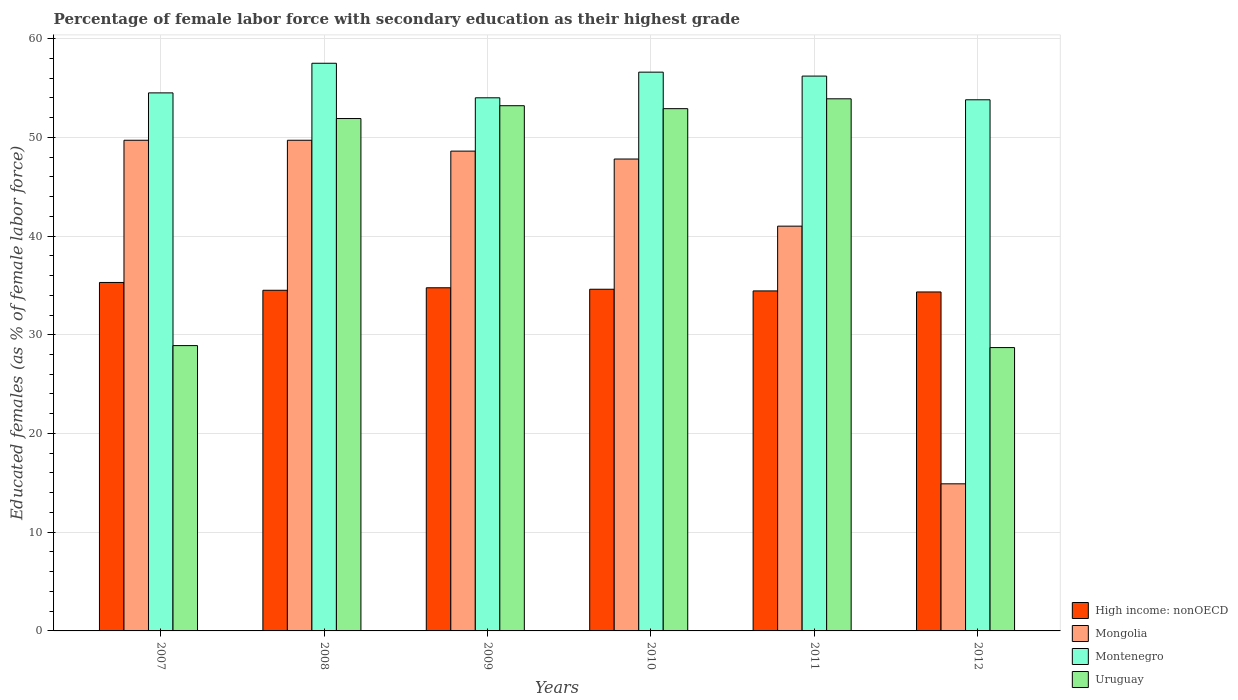How many groups of bars are there?
Your response must be concise. 6. How many bars are there on the 5th tick from the left?
Make the answer very short. 4. How many bars are there on the 1st tick from the right?
Give a very brief answer. 4. In how many cases, is the number of bars for a given year not equal to the number of legend labels?
Provide a succinct answer. 0. What is the percentage of female labor force with secondary education in Mongolia in 2008?
Provide a short and direct response. 49.7. Across all years, what is the maximum percentage of female labor force with secondary education in Uruguay?
Make the answer very short. 53.9. Across all years, what is the minimum percentage of female labor force with secondary education in Montenegro?
Offer a very short reply. 53.8. In which year was the percentage of female labor force with secondary education in Uruguay minimum?
Keep it short and to the point. 2012. What is the total percentage of female labor force with secondary education in High income: nonOECD in the graph?
Give a very brief answer. 207.94. What is the difference between the percentage of female labor force with secondary education in Montenegro in 2011 and that in 2012?
Offer a very short reply. 2.4. What is the difference between the percentage of female labor force with secondary education in Mongolia in 2009 and the percentage of female labor force with secondary education in Montenegro in 2012?
Your answer should be very brief. -5.2. What is the average percentage of female labor force with secondary education in Mongolia per year?
Offer a very short reply. 41.95. In the year 2009, what is the difference between the percentage of female labor force with secondary education in Uruguay and percentage of female labor force with secondary education in Montenegro?
Provide a short and direct response. -0.8. What is the ratio of the percentage of female labor force with secondary education in High income: nonOECD in 2008 to that in 2012?
Offer a very short reply. 1. Is the difference between the percentage of female labor force with secondary education in Uruguay in 2010 and 2012 greater than the difference between the percentage of female labor force with secondary education in Montenegro in 2010 and 2012?
Provide a succinct answer. Yes. What is the difference between the highest and the second highest percentage of female labor force with secondary education in Uruguay?
Your response must be concise. 0.7. What is the difference between the highest and the lowest percentage of female labor force with secondary education in High income: nonOECD?
Give a very brief answer. 0.96. In how many years, is the percentage of female labor force with secondary education in Uruguay greater than the average percentage of female labor force with secondary education in Uruguay taken over all years?
Your response must be concise. 4. What does the 4th bar from the left in 2012 represents?
Offer a very short reply. Uruguay. What does the 1st bar from the right in 2010 represents?
Keep it short and to the point. Uruguay. Are all the bars in the graph horizontal?
Your answer should be compact. No. Are the values on the major ticks of Y-axis written in scientific E-notation?
Your answer should be compact. No. Does the graph contain any zero values?
Give a very brief answer. No. Where does the legend appear in the graph?
Make the answer very short. Bottom right. What is the title of the graph?
Provide a succinct answer. Percentage of female labor force with secondary education as their highest grade. Does "Barbados" appear as one of the legend labels in the graph?
Give a very brief answer. No. What is the label or title of the X-axis?
Make the answer very short. Years. What is the label or title of the Y-axis?
Give a very brief answer. Educated females (as % of female labor force). What is the Educated females (as % of female labor force) of High income: nonOECD in 2007?
Provide a succinct answer. 35.3. What is the Educated females (as % of female labor force) in Mongolia in 2007?
Your answer should be very brief. 49.7. What is the Educated females (as % of female labor force) of Montenegro in 2007?
Ensure brevity in your answer.  54.5. What is the Educated females (as % of female labor force) in Uruguay in 2007?
Keep it short and to the point. 28.9. What is the Educated females (as % of female labor force) in High income: nonOECD in 2008?
Keep it short and to the point. 34.51. What is the Educated females (as % of female labor force) of Mongolia in 2008?
Your response must be concise. 49.7. What is the Educated females (as % of female labor force) in Montenegro in 2008?
Make the answer very short. 57.5. What is the Educated females (as % of female labor force) of Uruguay in 2008?
Give a very brief answer. 51.9. What is the Educated females (as % of female labor force) of High income: nonOECD in 2009?
Ensure brevity in your answer.  34.76. What is the Educated females (as % of female labor force) in Mongolia in 2009?
Provide a succinct answer. 48.6. What is the Educated females (as % of female labor force) of Montenegro in 2009?
Offer a very short reply. 54. What is the Educated females (as % of female labor force) of Uruguay in 2009?
Provide a short and direct response. 53.2. What is the Educated females (as % of female labor force) of High income: nonOECD in 2010?
Make the answer very short. 34.61. What is the Educated females (as % of female labor force) in Mongolia in 2010?
Your answer should be compact. 47.8. What is the Educated females (as % of female labor force) in Montenegro in 2010?
Your response must be concise. 56.6. What is the Educated females (as % of female labor force) in Uruguay in 2010?
Your response must be concise. 52.9. What is the Educated females (as % of female labor force) in High income: nonOECD in 2011?
Your answer should be compact. 34.44. What is the Educated females (as % of female labor force) of Mongolia in 2011?
Make the answer very short. 41. What is the Educated females (as % of female labor force) of Montenegro in 2011?
Your response must be concise. 56.2. What is the Educated females (as % of female labor force) of Uruguay in 2011?
Ensure brevity in your answer.  53.9. What is the Educated females (as % of female labor force) in High income: nonOECD in 2012?
Your response must be concise. 34.33. What is the Educated females (as % of female labor force) of Mongolia in 2012?
Your response must be concise. 14.9. What is the Educated females (as % of female labor force) of Montenegro in 2012?
Make the answer very short. 53.8. What is the Educated females (as % of female labor force) in Uruguay in 2012?
Your answer should be compact. 28.7. Across all years, what is the maximum Educated females (as % of female labor force) of High income: nonOECD?
Offer a terse response. 35.3. Across all years, what is the maximum Educated females (as % of female labor force) in Mongolia?
Make the answer very short. 49.7. Across all years, what is the maximum Educated females (as % of female labor force) in Montenegro?
Your answer should be compact. 57.5. Across all years, what is the maximum Educated females (as % of female labor force) in Uruguay?
Offer a terse response. 53.9. Across all years, what is the minimum Educated females (as % of female labor force) of High income: nonOECD?
Your answer should be compact. 34.33. Across all years, what is the minimum Educated females (as % of female labor force) in Mongolia?
Your answer should be very brief. 14.9. Across all years, what is the minimum Educated females (as % of female labor force) in Montenegro?
Your response must be concise. 53.8. Across all years, what is the minimum Educated females (as % of female labor force) of Uruguay?
Give a very brief answer. 28.7. What is the total Educated females (as % of female labor force) in High income: nonOECD in the graph?
Ensure brevity in your answer.  207.94. What is the total Educated females (as % of female labor force) in Mongolia in the graph?
Your answer should be compact. 251.7. What is the total Educated females (as % of female labor force) of Montenegro in the graph?
Give a very brief answer. 332.6. What is the total Educated females (as % of female labor force) of Uruguay in the graph?
Your answer should be very brief. 269.5. What is the difference between the Educated females (as % of female labor force) of High income: nonOECD in 2007 and that in 2008?
Your answer should be compact. 0.79. What is the difference between the Educated females (as % of female labor force) of Uruguay in 2007 and that in 2008?
Ensure brevity in your answer.  -23. What is the difference between the Educated females (as % of female labor force) of High income: nonOECD in 2007 and that in 2009?
Ensure brevity in your answer.  0.54. What is the difference between the Educated females (as % of female labor force) in Uruguay in 2007 and that in 2009?
Keep it short and to the point. -24.3. What is the difference between the Educated females (as % of female labor force) of High income: nonOECD in 2007 and that in 2010?
Offer a very short reply. 0.69. What is the difference between the Educated females (as % of female labor force) of Uruguay in 2007 and that in 2010?
Your answer should be compact. -24. What is the difference between the Educated females (as % of female labor force) in High income: nonOECD in 2007 and that in 2011?
Your answer should be compact. 0.86. What is the difference between the Educated females (as % of female labor force) in Mongolia in 2007 and that in 2011?
Provide a succinct answer. 8.7. What is the difference between the Educated females (as % of female labor force) of High income: nonOECD in 2007 and that in 2012?
Offer a very short reply. 0.96. What is the difference between the Educated females (as % of female labor force) in Mongolia in 2007 and that in 2012?
Your answer should be very brief. 34.8. What is the difference between the Educated females (as % of female labor force) in High income: nonOECD in 2008 and that in 2009?
Offer a terse response. -0.25. What is the difference between the Educated females (as % of female labor force) of Montenegro in 2008 and that in 2009?
Make the answer very short. 3.5. What is the difference between the Educated females (as % of female labor force) in Uruguay in 2008 and that in 2009?
Give a very brief answer. -1.3. What is the difference between the Educated females (as % of female labor force) of High income: nonOECD in 2008 and that in 2010?
Your answer should be very brief. -0.11. What is the difference between the Educated females (as % of female labor force) in Mongolia in 2008 and that in 2010?
Your response must be concise. 1.9. What is the difference between the Educated females (as % of female labor force) in Montenegro in 2008 and that in 2010?
Provide a short and direct response. 0.9. What is the difference between the Educated females (as % of female labor force) in High income: nonOECD in 2008 and that in 2011?
Provide a succinct answer. 0.07. What is the difference between the Educated females (as % of female labor force) in Mongolia in 2008 and that in 2011?
Ensure brevity in your answer.  8.7. What is the difference between the Educated females (as % of female labor force) of Montenegro in 2008 and that in 2011?
Give a very brief answer. 1.3. What is the difference between the Educated females (as % of female labor force) of Uruguay in 2008 and that in 2011?
Your response must be concise. -2. What is the difference between the Educated females (as % of female labor force) of High income: nonOECD in 2008 and that in 2012?
Your response must be concise. 0.17. What is the difference between the Educated females (as % of female labor force) in Mongolia in 2008 and that in 2012?
Offer a very short reply. 34.8. What is the difference between the Educated females (as % of female labor force) of Uruguay in 2008 and that in 2012?
Give a very brief answer. 23.2. What is the difference between the Educated females (as % of female labor force) of High income: nonOECD in 2009 and that in 2010?
Offer a terse response. 0.15. What is the difference between the Educated females (as % of female labor force) of Mongolia in 2009 and that in 2010?
Provide a short and direct response. 0.8. What is the difference between the Educated females (as % of female labor force) of Montenegro in 2009 and that in 2010?
Give a very brief answer. -2.6. What is the difference between the Educated females (as % of female labor force) of Uruguay in 2009 and that in 2010?
Provide a succinct answer. 0.3. What is the difference between the Educated females (as % of female labor force) of High income: nonOECD in 2009 and that in 2011?
Your answer should be compact. 0.32. What is the difference between the Educated females (as % of female labor force) in Montenegro in 2009 and that in 2011?
Ensure brevity in your answer.  -2.2. What is the difference between the Educated females (as % of female labor force) in Uruguay in 2009 and that in 2011?
Your answer should be very brief. -0.7. What is the difference between the Educated females (as % of female labor force) of High income: nonOECD in 2009 and that in 2012?
Provide a short and direct response. 0.42. What is the difference between the Educated females (as % of female labor force) in Mongolia in 2009 and that in 2012?
Make the answer very short. 33.7. What is the difference between the Educated females (as % of female labor force) in Uruguay in 2009 and that in 2012?
Provide a short and direct response. 24.5. What is the difference between the Educated females (as % of female labor force) in High income: nonOECD in 2010 and that in 2011?
Keep it short and to the point. 0.17. What is the difference between the Educated females (as % of female labor force) in High income: nonOECD in 2010 and that in 2012?
Make the answer very short. 0.28. What is the difference between the Educated females (as % of female labor force) in Mongolia in 2010 and that in 2012?
Provide a short and direct response. 32.9. What is the difference between the Educated females (as % of female labor force) of Uruguay in 2010 and that in 2012?
Provide a short and direct response. 24.2. What is the difference between the Educated females (as % of female labor force) of High income: nonOECD in 2011 and that in 2012?
Ensure brevity in your answer.  0.11. What is the difference between the Educated females (as % of female labor force) of Mongolia in 2011 and that in 2012?
Give a very brief answer. 26.1. What is the difference between the Educated females (as % of female labor force) in Uruguay in 2011 and that in 2012?
Ensure brevity in your answer.  25.2. What is the difference between the Educated females (as % of female labor force) of High income: nonOECD in 2007 and the Educated females (as % of female labor force) of Mongolia in 2008?
Offer a terse response. -14.4. What is the difference between the Educated females (as % of female labor force) of High income: nonOECD in 2007 and the Educated females (as % of female labor force) of Montenegro in 2008?
Make the answer very short. -22.2. What is the difference between the Educated females (as % of female labor force) in High income: nonOECD in 2007 and the Educated females (as % of female labor force) in Uruguay in 2008?
Your response must be concise. -16.6. What is the difference between the Educated females (as % of female labor force) of Mongolia in 2007 and the Educated females (as % of female labor force) of Uruguay in 2008?
Ensure brevity in your answer.  -2.2. What is the difference between the Educated females (as % of female labor force) in Montenegro in 2007 and the Educated females (as % of female labor force) in Uruguay in 2008?
Make the answer very short. 2.6. What is the difference between the Educated females (as % of female labor force) in High income: nonOECD in 2007 and the Educated females (as % of female labor force) in Mongolia in 2009?
Offer a very short reply. -13.3. What is the difference between the Educated females (as % of female labor force) in High income: nonOECD in 2007 and the Educated females (as % of female labor force) in Montenegro in 2009?
Provide a short and direct response. -18.7. What is the difference between the Educated females (as % of female labor force) in High income: nonOECD in 2007 and the Educated females (as % of female labor force) in Uruguay in 2009?
Offer a terse response. -17.9. What is the difference between the Educated females (as % of female labor force) of Mongolia in 2007 and the Educated females (as % of female labor force) of Uruguay in 2009?
Ensure brevity in your answer.  -3.5. What is the difference between the Educated females (as % of female labor force) in High income: nonOECD in 2007 and the Educated females (as % of female labor force) in Mongolia in 2010?
Offer a very short reply. -12.5. What is the difference between the Educated females (as % of female labor force) of High income: nonOECD in 2007 and the Educated females (as % of female labor force) of Montenegro in 2010?
Make the answer very short. -21.3. What is the difference between the Educated females (as % of female labor force) of High income: nonOECD in 2007 and the Educated females (as % of female labor force) of Uruguay in 2010?
Your response must be concise. -17.6. What is the difference between the Educated females (as % of female labor force) of Mongolia in 2007 and the Educated females (as % of female labor force) of Uruguay in 2010?
Give a very brief answer. -3.2. What is the difference between the Educated females (as % of female labor force) in Montenegro in 2007 and the Educated females (as % of female labor force) in Uruguay in 2010?
Your response must be concise. 1.6. What is the difference between the Educated females (as % of female labor force) in High income: nonOECD in 2007 and the Educated females (as % of female labor force) in Mongolia in 2011?
Make the answer very short. -5.7. What is the difference between the Educated females (as % of female labor force) in High income: nonOECD in 2007 and the Educated females (as % of female labor force) in Montenegro in 2011?
Offer a terse response. -20.9. What is the difference between the Educated females (as % of female labor force) of High income: nonOECD in 2007 and the Educated females (as % of female labor force) of Uruguay in 2011?
Ensure brevity in your answer.  -18.6. What is the difference between the Educated females (as % of female labor force) in Mongolia in 2007 and the Educated females (as % of female labor force) in Montenegro in 2011?
Make the answer very short. -6.5. What is the difference between the Educated females (as % of female labor force) in Mongolia in 2007 and the Educated females (as % of female labor force) in Uruguay in 2011?
Your response must be concise. -4.2. What is the difference between the Educated females (as % of female labor force) in Montenegro in 2007 and the Educated females (as % of female labor force) in Uruguay in 2011?
Give a very brief answer. 0.6. What is the difference between the Educated females (as % of female labor force) of High income: nonOECD in 2007 and the Educated females (as % of female labor force) of Mongolia in 2012?
Offer a very short reply. 20.4. What is the difference between the Educated females (as % of female labor force) in High income: nonOECD in 2007 and the Educated females (as % of female labor force) in Montenegro in 2012?
Keep it short and to the point. -18.5. What is the difference between the Educated females (as % of female labor force) in High income: nonOECD in 2007 and the Educated females (as % of female labor force) in Uruguay in 2012?
Ensure brevity in your answer.  6.6. What is the difference between the Educated females (as % of female labor force) in Mongolia in 2007 and the Educated females (as % of female labor force) in Uruguay in 2012?
Your answer should be very brief. 21. What is the difference between the Educated females (as % of female labor force) of Montenegro in 2007 and the Educated females (as % of female labor force) of Uruguay in 2012?
Make the answer very short. 25.8. What is the difference between the Educated females (as % of female labor force) in High income: nonOECD in 2008 and the Educated females (as % of female labor force) in Mongolia in 2009?
Keep it short and to the point. -14.09. What is the difference between the Educated females (as % of female labor force) in High income: nonOECD in 2008 and the Educated females (as % of female labor force) in Montenegro in 2009?
Your answer should be compact. -19.49. What is the difference between the Educated females (as % of female labor force) in High income: nonOECD in 2008 and the Educated females (as % of female labor force) in Uruguay in 2009?
Give a very brief answer. -18.69. What is the difference between the Educated females (as % of female labor force) in Mongolia in 2008 and the Educated females (as % of female labor force) in Uruguay in 2009?
Ensure brevity in your answer.  -3.5. What is the difference between the Educated females (as % of female labor force) of Montenegro in 2008 and the Educated females (as % of female labor force) of Uruguay in 2009?
Your answer should be compact. 4.3. What is the difference between the Educated females (as % of female labor force) in High income: nonOECD in 2008 and the Educated females (as % of female labor force) in Mongolia in 2010?
Ensure brevity in your answer.  -13.29. What is the difference between the Educated females (as % of female labor force) in High income: nonOECD in 2008 and the Educated females (as % of female labor force) in Montenegro in 2010?
Your answer should be compact. -22.09. What is the difference between the Educated females (as % of female labor force) in High income: nonOECD in 2008 and the Educated females (as % of female labor force) in Uruguay in 2010?
Your answer should be compact. -18.39. What is the difference between the Educated females (as % of female labor force) of Mongolia in 2008 and the Educated females (as % of female labor force) of Uruguay in 2010?
Your answer should be compact. -3.2. What is the difference between the Educated females (as % of female labor force) of Montenegro in 2008 and the Educated females (as % of female labor force) of Uruguay in 2010?
Ensure brevity in your answer.  4.6. What is the difference between the Educated females (as % of female labor force) of High income: nonOECD in 2008 and the Educated females (as % of female labor force) of Mongolia in 2011?
Your answer should be very brief. -6.49. What is the difference between the Educated females (as % of female labor force) in High income: nonOECD in 2008 and the Educated females (as % of female labor force) in Montenegro in 2011?
Make the answer very short. -21.69. What is the difference between the Educated females (as % of female labor force) in High income: nonOECD in 2008 and the Educated females (as % of female labor force) in Uruguay in 2011?
Your response must be concise. -19.39. What is the difference between the Educated females (as % of female labor force) of Mongolia in 2008 and the Educated females (as % of female labor force) of Uruguay in 2011?
Your response must be concise. -4.2. What is the difference between the Educated females (as % of female labor force) in Montenegro in 2008 and the Educated females (as % of female labor force) in Uruguay in 2011?
Your answer should be compact. 3.6. What is the difference between the Educated females (as % of female labor force) of High income: nonOECD in 2008 and the Educated females (as % of female labor force) of Mongolia in 2012?
Provide a succinct answer. 19.61. What is the difference between the Educated females (as % of female labor force) of High income: nonOECD in 2008 and the Educated females (as % of female labor force) of Montenegro in 2012?
Your response must be concise. -19.29. What is the difference between the Educated females (as % of female labor force) in High income: nonOECD in 2008 and the Educated females (as % of female labor force) in Uruguay in 2012?
Ensure brevity in your answer.  5.81. What is the difference between the Educated females (as % of female labor force) in Mongolia in 2008 and the Educated females (as % of female labor force) in Uruguay in 2012?
Your response must be concise. 21. What is the difference between the Educated females (as % of female labor force) of Montenegro in 2008 and the Educated females (as % of female labor force) of Uruguay in 2012?
Your response must be concise. 28.8. What is the difference between the Educated females (as % of female labor force) of High income: nonOECD in 2009 and the Educated females (as % of female labor force) of Mongolia in 2010?
Provide a short and direct response. -13.04. What is the difference between the Educated females (as % of female labor force) in High income: nonOECD in 2009 and the Educated females (as % of female labor force) in Montenegro in 2010?
Offer a terse response. -21.84. What is the difference between the Educated females (as % of female labor force) of High income: nonOECD in 2009 and the Educated females (as % of female labor force) of Uruguay in 2010?
Your answer should be very brief. -18.14. What is the difference between the Educated females (as % of female labor force) of Mongolia in 2009 and the Educated females (as % of female labor force) of Montenegro in 2010?
Your answer should be very brief. -8. What is the difference between the Educated females (as % of female labor force) of Montenegro in 2009 and the Educated females (as % of female labor force) of Uruguay in 2010?
Your response must be concise. 1.1. What is the difference between the Educated females (as % of female labor force) in High income: nonOECD in 2009 and the Educated females (as % of female labor force) in Mongolia in 2011?
Provide a short and direct response. -6.24. What is the difference between the Educated females (as % of female labor force) in High income: nonOECD in 2009 and the Educated females (as % of female labor force) in Montenegro in 2011?
Your response must be concise. -21.44. What is the difference between the Educated females (as % of female labor force) in High income: nonOECD in 2009 and the Educated females (as % of female labor force) in Uruguay in 2011?
Provide a short and direct response. -19.14. What is the difference between the Educated females (as % of female labor force) of Mongolia in 2009 and the Educated females (as % of female labor force) of Montenegro in 2011?
Offer a very short reply. -7.6. What is the difference between the Educated females (as % of female labor force) in Mongolia in 2009 and the Educated females (as % of female labor force) in Uruguay in 2011?
Your answer should be very brief. -5.3. What is the difference between the Educated females (as % of female labor force) in High income: nonOECD in 2009 and the Educated females (as % of female labor force) in Mongolia in 2012?
Provide a succinct answer. 19.86. What is the difference between the Educated females (as % of female labor force) in High income: nonOECD in 2009 and the Educated females (as % of female labor force) in Montenegro in 2012?
Your response must be concise. -19.04. What is the difference between the Educated females (as % of female labor force) in High income: nonOECD in 2009 and the Educated females (as % of female labor force) in Uruguay in 2012?
Keep it short and to the point. 6.06. What is the difference between the Educated females (as % of female labor force) of Mongolia in 2009 and the Educated females (as % of female labor force) of Uruguay in 2012?
Your answer should be very brief. 19.9. What is the difference between the Educated females (as % of female labor force) in Montenegro in 2009 and the Educated females (as % of female labor force) in Uruguay in 2012?
Keep it short and to the point. 25.3. What is the difference between the Educated females (as % of female labor force) of High income: nonOECD in 2010 and the Educated females (as % of female labor force) of Mongolia in 2011?
Your response must be concise. -6.39. What is the difference between the Educated females (as % of female labor force) in High income: nonOECD in 2010 and the Educated females (as % of female labor force) in Montenegro in 2011?
Offer a terse response. -21.59. What is the difference between the Educated females (as % of female labor force) of High income: nonOECD in 2010 and the Educated females (as % of female labor force) of Uruguay in 2011?
Provide a succinct answer. -19.29. What is the difference between the Educated females (as % of female labor force) of Montenegro in 2010 and the Educated females (as % of female labor force) of Uruguay in 2011?
Your response must be concise. 2.7. What is the difference between the Educated females (as % of female labor force) of High income: nonOECD in 2010 and the Educated females (as % of female labor force) of Mongolia in 2012?
Keep it short and to the point. 19.71. What is the difference between the Educated females (as % of female labor force) of High income: nonOECD in 2010 and the Educated females (as % of female labor force) of Montenegro in 2012?
Make the answer very short. -19.19. What is the difference between the Educated females (as % of female labor force) of High income: nonOECD in 2010 and the Educated females (as % of female labor force) of Uruguay in 2012?
Ensure brevity in your answer.  5.91. What is the difference between the Educated females (as % of female labor force) in Montenegro in 2010 and the Educated females (as % of female labor force) in Uruguay in 2012?
Provide a short and direct response. 27.9. What is the difference between the Educated females (as % of female labor force) in High income: nonOECD in 2011 and the Educated females (as % of female labor force) in Mongolia in 2012?
Keep it short and to the point. 19.54. What is the difference between the Educated females (as % of female labor force) of High income: nonOECD in 2011 and the Educated females (as % of female labor force) of Montenegro in 2012?
Your response must be concise. -19.36. What is the difference between the Educated females (as % of female labor force) in High income: nonOECD in 2011 and the Educated females (as % of female labor force) in Uruguay in 2012?
Keep it short and to the point. 5.74. What is the difference between the Educated females (as % of female labor force) of Mongolia in 2011 and the Educated females (as % of female labor force) of Montenegro in 2012?
Your answer should be compact. -12.8. What is the difference between the Educated females (as % of female labor force) of Mongolia in 2011 and the Educated females (as % of female labor force) of Uruguay in 2012?
Keep it short and to the point. 12.3. What is the average Educated females (as % of female labor force) in High income: nonOECD per year?
Provide a short and direct response. 34.66. What is the average Educated females (as % of female labor force) of Mongolia per year?
Your answer should be compact. 41.95. What is the average Educated females (as % of female labor force) in Montenegro per year?
Keep it short and to the point. 55.43. What is the average Educated females (as % of female labor force) in Uruguay per year?
Offer a very short reply. 44.92. In the year 2007, what is the difference between the Educated females (as % of female labor force) in High income: nonOECD and Educated females (as % of female labor force) in Mongolia?
Offer a very short reply. -14.4. In the year 2007, what is the difference between the Educated females (as % of female labor force) in High income: nonOECD and Educated females (as % of female labor force) in Montenegro?
Provide a short and direct response. -19.2. In the year 2007, what is the difference between the Educated females (as % of female labor force) of High income: nonOECD and Educated females (as % of female labor force) of Uruguay?
Ensure brevity in your answer.  6.4. In the year 2007, what is the difference between the Educated females (as % of female labor force) in Mongolia and Educated females (as % of female labor force) in Uruguay?
Your answer should be very brief. 20.8. In the year 2007, what is the difference between the Educated females (as % of female labor force) of Montenegro and Educated females (as % of female labor force) of Uruguay?
Provide a succinct answer. 25.6. In the year 2008, what is the difference between the Educated females (as % of female labor force) in High income: nonOECD and Educated females (as % of female labor force) in Mongolia?
Provide a succinct answer. -15.19. In the year 2008, what is the difference between the Educated females (as % of female labor force) of High income: nonOECD and Educated females (as % of female labor force) of Montenegro?
Give a very brief answer. -22.99. In the year 2008, what is the difference between the Educated females (as % of female labor force) in High income: nonOECD and Educated females (as % of female labor force) in Uruguay?
Offer a very short reply. -17.39. In the year 2009, what is the difference between the Educated females (as % of female labor force) of High income: nonOECD and Educated females (as % of female labor force) of Mongolia?
Your answer should be compact. -13.84. In the year 2009, what is the difference between the Educated females (as % of female labor force) in High income: nonOECD and Educated females (as % of female labor force) in Montenegro?
Provide a short and direct response. -19.24. In the year 2009, what is the difference between the Educated females (as % of female labor force) in High income: nonOECD and Educated females (as % of female labor force) in Uruguay?
Make the answer very short. -18.44. In the year 2009, what is the difference between the Educated females (as % of female labor force) of Montenegro and Educated females (as % of female labor force) of Uruguay?
Ensure brevity in your answer.  0.8. In the year 2010, what is the difference between the Educated females (as % of female labor force) in High income: nonOECD and Educated females (as % of female labor force) in Mongolia?
Provide a short and direct response. -13.19. In the year 2010, what is the difference between the Educated females (as % of female labor force) in High income: nonOECD and Educated females (as % of female labor force) in Montenegro?
Ensure brevity in your answer.  -21.99. In the year 2010, what is the difference between the Educated females (as % of female labor force) in High income: nonOECD and Educated females (as % of female labor force) in Uruguay?
Provide a short and direct response. -18.29. In the year 2010, what is the difference between the Educated females (as % of female labor force) of Mongolia and Educated females (as % of female labor force) of Uruguay?
Keep it short and to the point. -5.1. In the year 2011, what is the difference between the Educated females (as % of female labor force) of High income: nonOECD and Educated females (as % of female labor force) of Mongolia?
Give a very brief answer. -6.56. In the year 2011, what is the difference between the Educated females (as % of female labor force) in High income: nonOECD and Educated females (as % of female labor force) in Montenegro?
Your answer should be very brief. -21.76. In the year 2011, what is the difference between the Educated females (as % of female labor force) in High income: nonOECD and Educated females (as % of female labor force) in Uruguay?
Your answer should be compact. -19.46. In the year 2011, what is the difference between the Educated females (as % of female labor force) in Mongolia and Educated females (as % of female labor force) in Montenegro?
Provide a succinct answer. -15.2. In the year 2011, what is the difference between the Educated females (as % of female labor force) in Mongolia and Educated females (as % of female labor force) in Uruguay?
Make the answer very short. -12.9. In the year 2011, what is the difference between the Educated females (as % of female labor force) of Montenegro and Educated females (as % of female labor force) of Uruguay?
Give a very brief answer. 2.3. In the year 2012, what is the difference between the Educated females (as % of female labor force) of High income: nonOECD and Educated females (as % of female labor force) of Mongolia?
Ensure brevity in your answer.  19.43. In the year 2012, what is the difference between the Educated females (as % of female labor force) of High income: nonOECD and Educated females (as % of female labor force) of Montenegro?
Offer a terse response. -19.47. In the year 2012, what is the difference between the Educated females (as % of female labor force) in High income: nonOECD and Educated females (as % of female labor force) in Uruguay?
Ensure brevity in your answer.  5.63. In the year 2012, what is the difference between the Educated females (as % of female labor force) in Mongolia and Educated females (as % of female labor force) in Montenegro?
Make the answer very short. -38.9. In the year 2012, what is the difference between the Educated females (as % of female labor force) of Mongolia and Educated females (as % of female labor force) of Uruguay?
Provide a short and direct response. -13.8. In the year 2012, what is the difference between the Educated females (as % of female labor force) in Montenegro and Educated females (as % of female labor force) in Uruguay?
Give a very brief answer. 25.1. What is the ratio of the Educated females (as % of female labor force) of High income: nonOECD in 2007 to that in 2008?
Offer a terse response. 1.02. What is the ratio of the Educated females (as % of female labor force) of Montenegro in 2007 to that in 2008?
Offer a very short reply. 0.95. What is the ratio of the Educated females (as % of female labor force) in Uruguay in 2007 to that in 2008?
Your response must be concise. 0.56. What is the ratio of the Educated females (as % of female labor force) in High income: nonOECD in 2007 to that in 2009?
Offer a terse response. 1.02. What is the ratio of the Educated females (as % of female labor force) in Mongolia in 2007 to that in 2009?
Your response must be concise. 1.02. What is the ratio of the Educated females (as % of female labor force) of Montenegro in 2007 to that in 2009?
Offer a very short reply. 1.01. What is the ratio of the Educated females (as % of female labor force) of Uruguay in 2007 to that in 2009?
Offer a terse response. 0.54. What is the ratio of the Educated females (as % of female labor force) in High income: nonOECD in 2007 to that in 2010?
Offer a very short reply. 1.02. What is the ratio of the Educated females (as % of female labor force) of Mongolia in 2007 to that in 2010?
Provide a succinct answer. 1.04. What is the ratio of the Educated females (as % of female labor force) in Montenegro in 2007 to that in 2010?
Keep it short and to the point. 0.96. What is the ratio of the Educated females (as % of female labor force) in Uruguay in 2007 to that in 2010?
Keep it short and to the point. 0.55. What is the ratio of the Educated females (as % of female labor force) of High income: nonOECD in 2007 to that in 2011?
Ensure brevity in your answer.  1.02. What is the ratio of the Educated females (as % of female labor force) of Mongolia in 2007 to that in 2011?
Offer a terse response. 1.21. What is the ratio of the Educated females (as % of female labor force) of Montenegro in 2007 to that in 2011?
Your answer should be compact. 0.97. What is the ratio of the Educated females (as % of female labor force) of Uruguay in 2007 to that in 2011?
Offer a terse response. 0.54. What is the ratio of the Educated females (as % of female labor force) of High income: nonOECD in 2007 to that in 2012?
Provide a succinct answer. 1.03. What is the ratio of the Educated females (as % of female labor force) in Mongolia in 2007 to that in 2012?
Provide a succinct answer. 3.34. What is the ratio of the Educated females (as % of female labor force) of Uruguay in 2007 to that in 2012?
Offer a very short reply. 1.01. What is the ratio of the Educated females (as % of female labor force) in High income: nonOECD in 2008 to that in 2009?
Your answer should be compact. 0.99. What is the ratio of the Educated females (as % of female labor force) in Mongolia in 2008 to that in 2009?
Give a very brief answer. 1.02. What is the ratio of the Educated females (as % of female labor force) in Montenegro in 2008 to that in 2009?
Provide a succinct answer. 1.06. What is the ratio of the Educated females (as % of female labor force) in Uruguay in 2008 to that in 2009?
Give a very brief answer. 0.98. What is the ratio of the Educated females (as % of female labor force) in High income: nonOECD in 2008 to that in 2010?
Ensure brevity in your answer.  1. What is the ratio of the Educated females (as % of female labor force) of Mongolia in 2008 to that in 2010?
Offer a very short reply. 1.04. What is the ratio of the Educated females (as % of female labor force) in Montenegro in 2008 to that in 2010?
Keep it short and to the point. 1.02. What is the ratio of the Educated females (as % of female labor force) in Uruguay in 2008 to that in 2010?
Provide a short and direct response. 0.98. What is the ratio of the Educated females (as % of female labor force) of Mongolia in 2008 to that in 2011?
Keep it short and to the point. 1.21. What is the ratio of the Educated females (as % of female labor force) in Montenegro in 2008 to that in 2011?
Make the answer very short. 1.02. What is the ratio of the Educated females (as % of female labor force) of Uruguay in 2008 to that in 2011?
Make the answer very short. 0.96. What is the ratio of the Educated females (as % of female labor force) of Mongolia in 2008 to that in 2012?
Your response must be concise. 3.34. What is the ratio of the Educated females (as % of female labor force) of Montenegro in 2008 to that in 2012?
Give a very brief answer. 1.07. What is the ratio of the Educated females (as % of female labor force) in Uruguay in 2008 to that in 2012?
Provide a short and direct response. 1.81. What is the ratio of the Educated females (as % of female labor force) of High income: nonOECD in 2009 to that in 2010?
Your answer should be very brief. 1. What is the ratio of the Educated females (as % of female labor force) in Mongolia in 2009 to that in 2010?
Your answer should be very brief. 1.02. What is the ratio of the Educated females (as % of female labor force) in Montenegro in 2009 to that in 2010?
Your response must be concise. 0.95. What is the ratio of the Educated females (as % of female labor force) in Uruguay in 2009 to that in 2010?
Offer a terse response. 1.01. What is the ratio of the Educated females (as % of female labor force) in High income: nonOECD in 2009 to that in 2011?
Give a very brief answer. 1.01. What is the ratio of the Educated females (as % of female labor force) in Mongolia in 2009 to that in 2011?
Make the answer very short. 1.19. What is the ratio of the Educated females (as % of female labor force) of Montenegro in 2009 to that in 2011?
Keep it short and to the point. 0.96. What is the ratio of the Educated females (as % of female labor force) in High income: nonOECD in 2009 to that in 2012?
Give a very brief answer. 1.01. What is the ratio of the Educated females (as % of female labor force) of Mongolia in 2009 to that in 2012?
Your answer should be compact. 3.26. What is the ratio of the Educated females (as % of female labor force) of Montenegro in 2009 to that in 2012?
Offer a terse response. 1. What is the ratio of the Educated females (as % of female labor force) of Uruguay in 2009 to that in 2012?
Keep it short and to the point. 1.85. What is the ratio of the Educated females (as % of female labor force) in High income: nonOECD in 2010 to that in 2011?
Your answer should be very brief. 1. What is the ratio of the Educated females (as % of female labor force) of Mongolia in 2010 to that in 2011?
Make the answer very short. 1.17. What is the ratio of the Educated females (as % of female labor force) of Montenegro in 2010 to that in 2011?
Provide a short and direct response. 1.01. What is the ratio of the Educated females (as % of female labor force) in Uruguay in 2010 to that in 2011?
Ensure brevity in your answer.  0.98. What is the ratio of the Educated females (as % of female labor force) in Mongolia in 2010 to that in 2012?
Offer a terse response. 3.21. What is the ratio of the Educated females (as % of female labor force) in Montenegro in 2010 to that in 2012?
Provide a short and direct response. 1.05. What is the ratio of the Educated females (as % of female labor force) in Uruguay in 2010 to that in 2012?
Give a very brief answer. 1.84. What is the ratio of the Educated females (as % of female labor force) of Mongolia in 2011 to that in 2012?
Provide a short and direct response. 2.75. What is the ratio of the Educated females (as % of female labor force) in Montenegro in 2011 to that in 2012?
Offer a very short reply. 1.04. What is the ratio of the Educated females (as % of female labor force) in Uruguay in 2011 to that in 2012?
Your response must be concise. 1.88. What is the difference between the highest and the second highest Educated females (as % of female labor force) in High income: nonOECD?
Ensure brevity in your answer.  0.54. What is the difference between the highest and the second highest Educated females (as % of female labor force) in Mongolia?
Offer a terse response. 0. What is the difference between the highest and the second highest Educated females (as % of female labor force) in Uruguay?
Your answer should be compact. 0.7. What is the difference between the highest and the lowest Educated females (as % of female labor force) in High income: nonOECD?
Your answer should be compact. 0.96. What is the difference between the highest and the lowest Educated females (as % of female labor force) of Mongolia?
Give a very brief answer. 34.8. What is the difference between the highest and the lowest Educated females (as % of female labor force) in Montenegro?
Give a very brief answer. 3.7. What is the difference between the highest and the lowest Educated females (as % of female labor force) of Uruguay?
Offer a terse response. 25.2. 